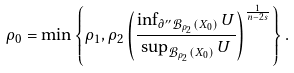Convert formula to latex. <formula><loc_0><loc_0><loc_500><loc_500>\rho _ { 0 } = \min \left \{ \rho _ { 1 } , \rho _ { 2 } \left ( \frac { \inf _ { \partial ^ { \prime \prime } \mathcal { B } _ { \rho _ { 2 } } ( X _ { 0 } ) } U } { \sup _ { \mathcal { B } _ { \rho _ { 2 } } ( X _ { 0 } ) } U } \right ) ^ { \frac { 1 } { n - 2 s } } \right \} .</formula> 